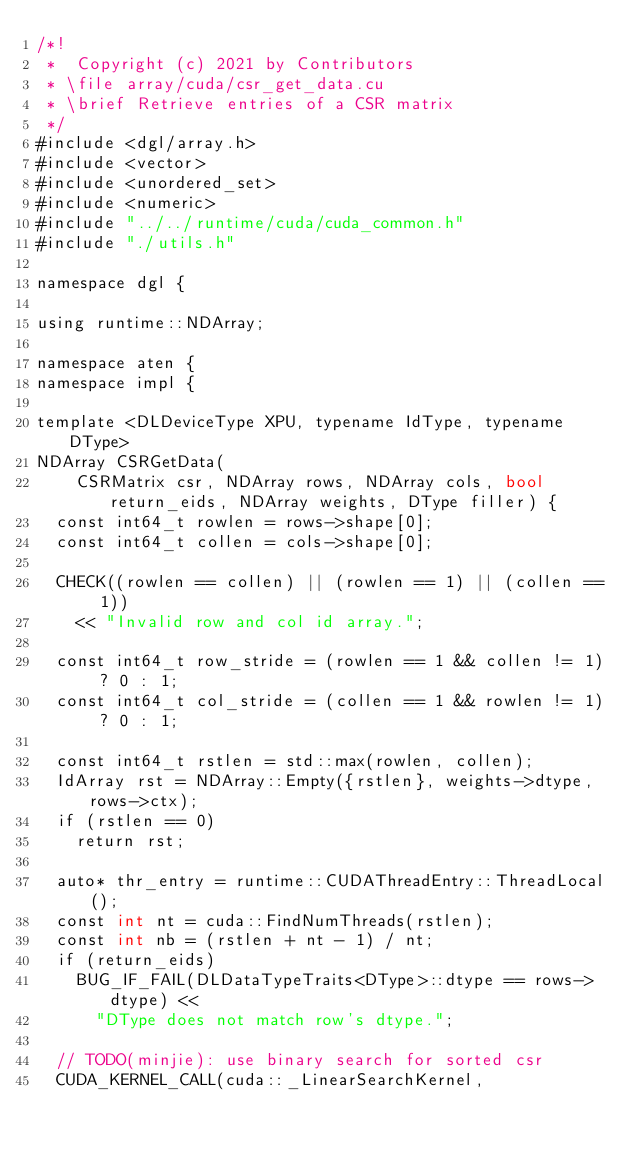Convert code to text. <code><loc_0><loc_0><loc_500><loc_500><_Cuda_>/*!
 *  Copyright (c) 2021 by Contributors
 * \file array/cuda/csr_get_data.cu
 * \brief Retrieve entries of a CSR matrix
 */
#include <dgl/array.h>
#include <vector>
#include <unordered_set>
#include <numeric>
#include "../../runtime/cuda/cuda_common.h"
#include "./utils.h"

namespace dgl {

using runtime::NDArray;

namespace aten {
namespace impl {

template <DLDeviceType XPU, typename IdType, typename DType>
NDArray CSRGetData(
    CSRMatrix csr, NDArray rows, NDArray cols, bool return_eids, NDArray weights, DType filler) {
  const int64_t rowlen = rows->shape[0];
  const int64_t collen = cols->shape[0];

  CHECK((rowlen == collen) || (rowlen == 1) || (collen == 1))
    << "Invalid row and col id array.";

  const int64_t row_stride = (rowlen == 1 && collen != 1) ? 0 : 1;
  const int64_t col_stride = (collen == 1 && rowlen != 1) ? 0 : 1;

  const int64_t rstlen = std::max(rowlen, collen);
  IdArray rst = NDArray::Empty({rstlen}, weights->dtype, rows->ctx);
  if (rstlen == 0)
    return rst;

  auto* thr_entry = runtime::CUDAThreadEntry::ThreadLocal();
  const int nt = cuda::FindNumThreads(rstlen);
  const int nb = (rstlen + nt - 1) / nt;
  if (return_eids)
    BUG_IF_FAIL(DLDataTypeTraits<DType>::dtype == rows->dtype) <<
      "DType does not match row's dtype.";

  // TODO(minjie): use binary search for sorted csr
  CUDA_KERNEL_CALL(cuda::_LinearSearchKernel,</code> 